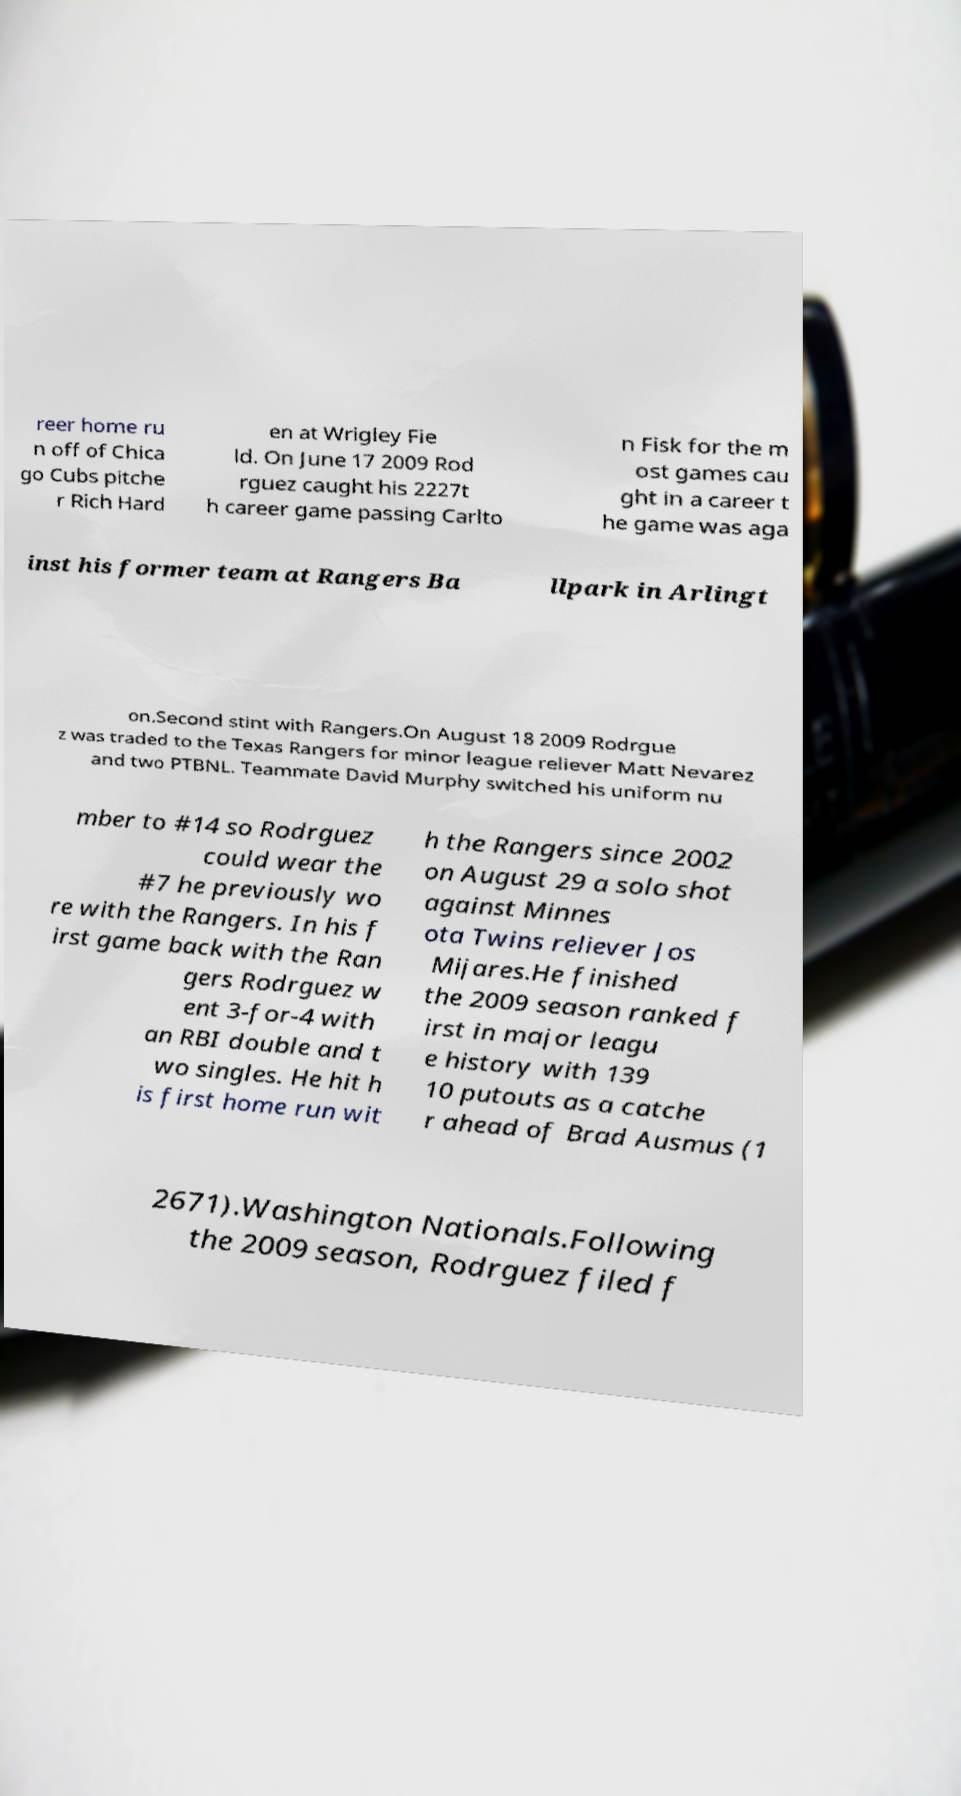There's text embedded in this image that I need extracted. Can you transcribe it verbatim? reer home ru n off of Chica go Cubs pitche r Rich Hard en at Wrigley Fie ld. On June 17 2009 Rod rguez caught his 2227t h career game passing Carlto n Fisk for the m ost games cau ght in a career t he game was aga inst his former team at Rangers Ba llpark in Arlingt on.Second stint with Rangers.On August 18 2009 Rodrgue z was traded to the Texas Rangers for minor league reliever Matt Nevarez and two PTBNL. Teammate David Murphy switched his uniform nu mber to #14 so Rodrguez could wear the #7 he previously wo re with the Rangers. In his f irst game back with the Ran gers Rodrguez w ent 3-for-4 with an RBI double and t wo singles. He hit h is first home run wit h the Rangers since 2002 on August 29 a solo shot against Minnes ota Twins reliever Jos Mijares.He finished the 2009 season ranked f irst in major leagu e history with 139 10 putouts as a catche r ahead of Brad Ausmus (1 2671).Washington Nationals.Following the 2009 season, Rodrguez filed f 